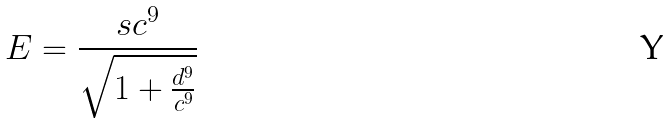Convert formula to latex. <formula><loc_0><loc_0><loc_500><loc_500>E = \frac { s c ^ { 9 } } { \sqrt { 1 + \frac { d ^ { 9 } } { c ^ { 9 } } } }</formula> 